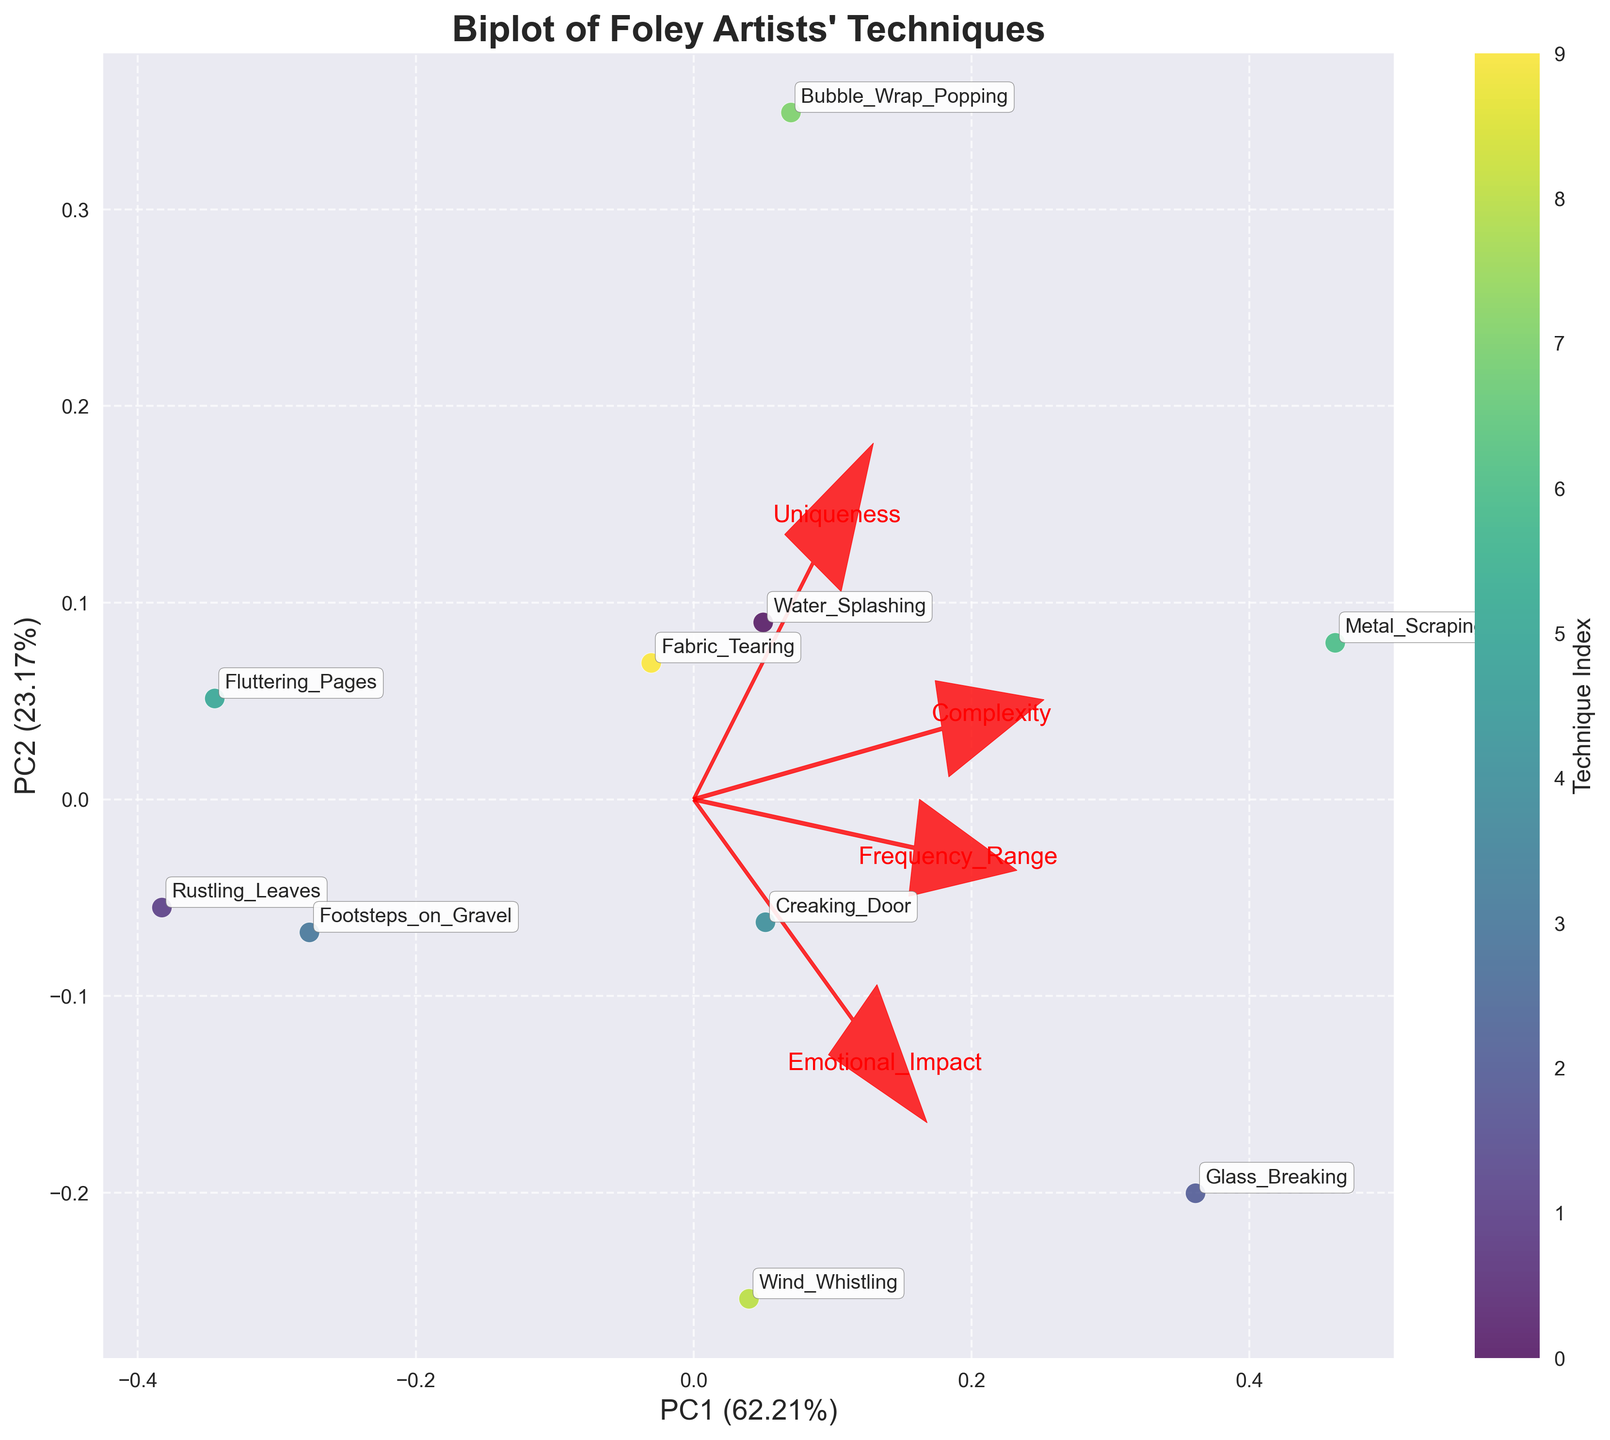What is the title of the biplot? The biplot title is typically located at the top of the figure. It provides a summary or main subject of the visualization.
Answer: "Biplot of Foley Artists' Techniques" How many data points are represented in the biplot? Each data point corresponds to a specific Foley technique, which is named and annotated in the plot. The total number of named points gives the answer.
Answer: 10 Which Foley technique has the highest value on the first principal component (PC1)? To identify this, find the point furthest to the right along the PC1 axis. The annotation will provide the technique name.
Answer: Bubble_Wrap_Popping Which feature has the largest loading value in the negative direction on PC2? The loadings are represented by red arrows. To determine the feature with the largest negative loading on PC2, identify the arrow pointing most downward along the PC2 axis and read the feature name next to it.
Answer: Frequency_Range What is the approximate explained variance ratio of PC1? The explained variance is usually labeled on the axes. For PC1, look at the percentage value mentioned in the label of the x-axis.
Answer: ~51.50% Which Foley technique has a high uniqueness but a low emotional impact based on the plot position? Find the Foley techniques located towards the right (high uniqueness) and down (low emotional impact). Identify the technique with these characteristics by its annotation.
Answer: Bubble_Wrap_Popping Which two Foley techniques are most similar in their PCA scores? Find two points that are closest to each other visually on the plot. The annotations will give their names.
Answer: Footsteps_on_Gravel and Fluttering_Pages How do the techniques with high emotional impact generally align on the PC2 axis? Identify the techniques with high emotional impact by looking at the red arrow direction for "Emotional_Impact." See where these techniques are positioned along the PC2 axis.
Answer: They align towards the upper part of PC2 What's the direction of the "Complexity" feature loading? Note the direction in which the red arrow labeled "Complexity" points. It tells you if it has a positive or negative impact on each principal component.
Answer: Positive on PC1 and PC2 Which two principal components explain the total variance in the data? The title and axis annotations usually contain information about how much variance each principal component explains. Summing these percentages gives the total explained variance.
Answer: PC1 and PC2 